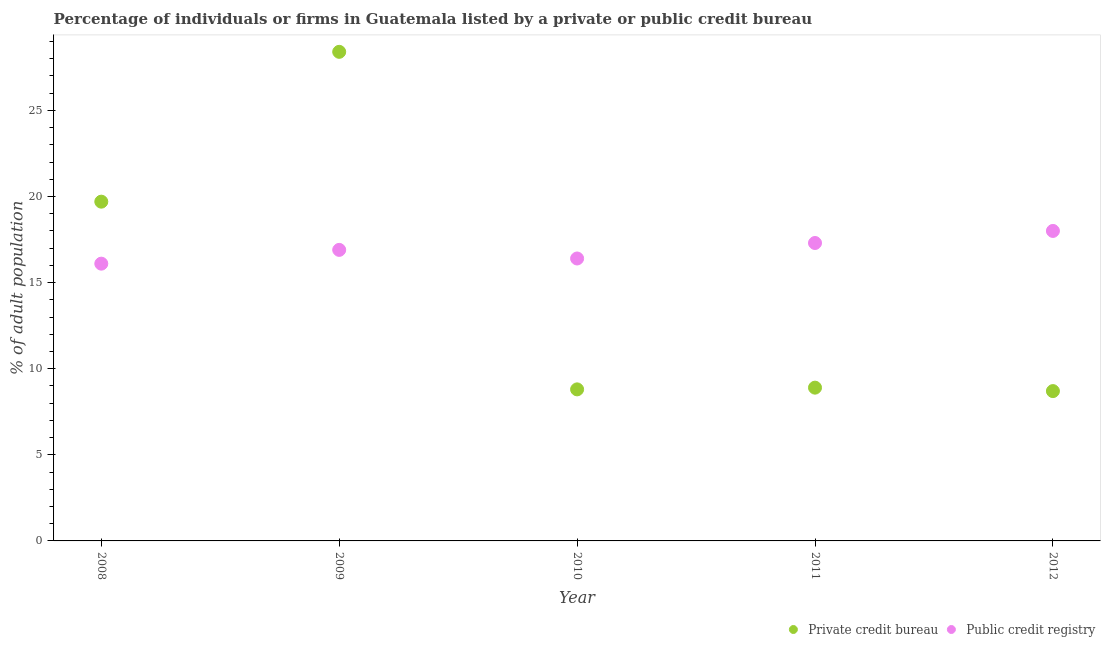How many different coloured dotlines are there?
Keep it short and to the point. 2. What is the percentage of firms listed by private credit bureau in 2008?
Keep it short and to the point. 19.7. What is the total percentage of firms listed by public credit bureau in the graph?
Give a very brief answer. 84.7. What is the difference between the percentage of firms listed by private credit bureau in 2011 and that in 2012?
Give a very brief answer. 0.2. What is the difference between the percentage of firms listed by public credit bureau in 2011 and the percentage of firms listed by private credit bureau in 2012?
Provide a short and direct response. 8.6. What is the average percentage of firms listed by public credit bureau per year?
Provide a succinct answer. 16.94. What is the ratio of the percentage of firms listed by public credit bureau in 2008 to that in 2009?
Ensure brevity in your answer.  0.95. Is the percentage of firms listed by private credit bureau in 2009 less than that in 2012?
Provide a short and direct response. No. Is the difference between the percentage of firms listed by public credit bureau in 2010 and 2011 greater than the difference between the percentage of firms listed by private credit bureau in 2010 and 2011?
Make the answer very short. No. What is the difference between the highest and the lowest percentage of firms listed by public credit bureau?
Provide a short and direct response. 1.9. Is the sum of the percentage of firms listed by public credit bureau in 2010 and 2012 greater than the maximum percentage of firms listed by private credit bureau across all years?
Provide a succinct answer. Yes. Does the percentage of firms listed by private credit bureau monotonically increase over the years?
Keep it short and to the point. No. Is the percentage of firms listed by private credit bureau strictly less than the percentage of firms listed by public credit bureau over the years?
Offer a very short reply. No. How many years are there in the graph?
Give a very brief answer. 5. Are the values on the major ticks of Y-axis written in scientific E-notation?
Your response must be concise. No. Does the graph contain any zero values?
Provide a succinct answer. No. Does the graph contain grids?
Give a very brief answer. No. How are the legend labels stacked?
Offer a very short reply. Horizontal. What is the title of the graph?
Keep it short and to the point. Percentage of individuals or firms in Guatemala listed by a private or public credit bureau. What is the label or title of the Y-axis?
Your answer should be very brief. % of adult population. What is the % of adult population of Private credit bureau in 2009?
Provide a succinct answer. 28.4. What is the % of adult population in Public credit registry in 2009?
Your answer should be compact. 16.9. What is the % of adult population in Private credit bureau in 2010?
Offer a terse response. 8.8. What is the % of adult population in Private credit bureau in 2011?
Give a very brief answer. 8.9. What is the % of adult population in Public credit registry in 2011?
Ensure brevity in your answer.  17.3. Across all years, what is the maximum % of adult population of Private credit bureau?
Provide a short and direct response. 28.4. Across all years, what is the minimum % of adult population of Public credit registry?
Your answer should be very brief. 16.1. What is the total % of adult population in Private credit bureau in the graph?
Give a very brief answer. 74.5. What is the total % of adult population of Public credit registry in the graph?
Provide a succinct answer. 84.7. What is the difference between the % of adult population of Private credit bureau in 2008 and that in 2009?
Offer a very short reply. -8.7. What is the difference between the % of adult population of Private credit bureau in 2008 and that in 2010?
Ensure brevity in your answer.  10.9. What is the difference between the % of adult population of Public credit registry in 2008 and that in 2010?
Keep it short and to the point. -0.3. What is the difference between the % of adult population in Private credit bureau in 2008 and that in 2011?
Keep it short and to the point. 10.8. What is the difference between the % of adult population in Private credit bureau in 2008 and that in 2012?
Make the answer very short. 11. What is the difference between the % of adult population of Private credit bureau in 2009 and that in 2010?
Give a very brief answer. 19.6. What is the difference between the % of adult population in Public credit registry in 2009 and that in 2010?
Ensure brevity in your answer.  0.5. What is the difference between the % of adult population in Private credit bureau in 2009 and that in 2011?
Make the answer very short. 19.5. What is the difference between the % of adult population in Private credit bureau in 2009 and that in 2012?
Your answer should be very brief. 19.7. What is the difference between the % of adult population of Private credit bureau in 2010 and that in 2011?
Keep it short and to the point. -0.1. What is the difference between the % of adult population in Private credit bureau in 2010 and that in 2012?
Your answer should be compact. 0.1. What is the difference between the % of adult population in Private credit bureau in 2008 and the % of adult population in Public credit registry in 2010?
Offer a very short reply. 3.3. What is the difference between the % of adult population of Private credit bureau in 2008 and the % of adult population of Public credit registry in 2011?
Make the answer very short. 2.4. What is the difference between the % of adult population of Private credit bureau in 2009 and the % of adult population of Public credit registry in 2010?
Ensure brevity in your answer.  12. What is the difference between the % of adult population of Private credit bureau in 2009 and the % of adult population of Public credit registry in 2011?
Ensure brevity in your answer.  11.1. What is the difference between the % of adult population of Private credit bureau in 2009 and the % of adult population of Public credit registry in 2012?
Your response must be concise. 10.4. What is the difference between the % of adult population of Private credit bureau in 2010 and the % of adult population of Public credit registry in 2011?
Offer a terse response. -8.5. What is the difference between the % of adult population of Private credit bureau in 2011 and the % of adult population of Public credit registry in 2012?
Keep it short and to the point. -9.1. What is the average % of adult population in Private credit bureau per year?
Ensure brevity in your answer.  14.9. What is the average % of adult population of Public credit registry per year?
Your answer should be very brief. 16.94. In the year 2009, what is the difference between the % of adult population in Private credit bureau and % of adult population in Public credit registry?
Make the answer very short. 11.5. In the year 2010, what is the difference between the % of adult population of Private credit bureau and % of adult population of Public credit registry?
Provide a short and direct response. -7.6. What is the ratio of the % of adult population in Private credit bureau in 2008 to that in 2009?
Make the answer very short. 0.69. What is the ratio of the % of adult population of Public credit registry in 2008 to that in 2009?
Provide a short and direct response. 0.95. What is the ratio of the % of adult population of Private credit bureau in 2008 to that in 2010?
Give a very brief answer. 2.24. What is the ratio of the % of adult population of Public credit registry in 2008 to that in 2010?
Make the answer very short. 0.98. What is the ratio of the % of adult population in Private credit bureau in 2008 to that in 2011?
Provide a succinct answer. 2.21. What is the ratio of the % of adult population in Public credit registry in 2008 to that in 2011?
Ensure brevity in your answer.  0.93. What is the ratio of the % of adult population in Private credit bureau in 2008 to that in 2012?
Provide a succinct answer. 2.26. What is the ratio of the % of adult population in Public credit registry in 2008 to that in 2012?
Provide a succinct answer. 0.89. What is the ratio of the % of adult population in Private credit bureau in 2009 to that in 2010?
Ensure brevity in your answer.  3.23. What is the ratio of the % of adult population of Public credit registry in 2009 to that in 2010?
Make the answer very short. 1.03. What is the ratio of the % of adult population of Private credit bureau in 2009 to that in 2011?
Make the answer very short. 3.19. What is the ratio of the % of adult population in Public credit registry in 2009 to that in 2011?
Provide a short and direct response. 0.98. What is the ratio of the % of adult population of Private credit bureau in 2009 to that in 2012?
Ensure brevity in your answer.  3.26. What is the ratio of the % of adult population of Public credit registry in 2009 to that in 2012?
Your answer should be very brief. 0.94. What is the ratio of the % of adult population in Private credit bureau in 2010 to that in 2011?
Offer a terse response. 0.99. What is the ratio of the % of adult population in Public credit registry in 2010 to that in 2011?
Offer a very short reply. 0.95. What is the ratio of the % of adult population in Private credit bureau in 2010 to that in 2012?
Keep it short and to the point. 1.01. What is the ratio of the % of adult population in Public credit registry in 2010 to that in 2012?
Your answer should be very brief. 0.91. What is the ratio of the % of adult population in Private credit bureau in 2011 to that in 2012?
Provide a short and direct response. 1.02. What is the ratio of the % of adult population of Public credit registry in 2011 to that in 2012?
Make the answer very short. 0.96. What is the difference between the highest and the second highest % of adult population in Private credit bureau?
Offer a very short reply. 8.7. What is the difference between the highest and the second highest % of adult population of Public credit registry?
Provide a short and direct response. 0.7. What is the difference between the highest and the lowest % of adult population in Private credit bureau?
Your answer should be very brief. 19.7. What is the difference between the highest and the lowest % of adult population in Public credit registry?
Your response must be concise. 1.9. 